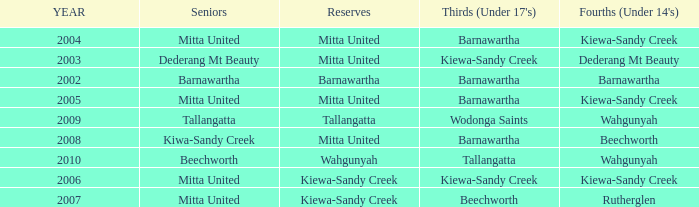Which Fourths (Under 14's) have Seniors of dederang mt beauty? Dederang Mt Beauty. 